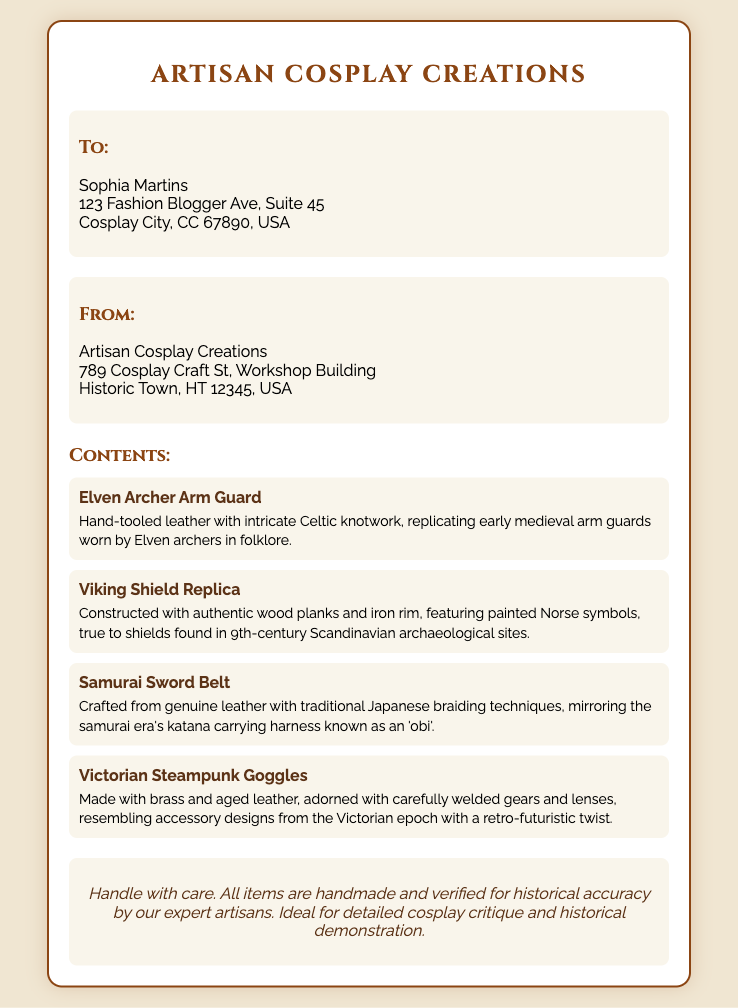What is the name of the recipient? The recipient's name is listed in the 'To' section of the label.
Answer: Sophia Martins What is the shipping origin city? The origin city is provided in the 'From' section of the label.
Answer: Historic Town What item features Celtic knotwork? The item description mentions Celtic knotwork specifically for the arm guard.
Answer: Elven Archer Arm Guard How many items are listed in the contents? The total items can be counted from the list under 'Contents'.
Answer: Four What material is the Viking Shield Replica made from? The item description states the materials used for the Viking Shield Replica.
Answer: Authentic wood planks and iron rim What are the special instructions for handling the items? The instructions highlight how the items should be treated during shipping.
Answer: Handle with care What is the historical period for the samurai sword belt? The belt's description refers to a specific historical context.
Answer: Samurai era What type of craftsmanship is emphasized for the items? The description includes the quality and attention to detail in creating the items.
Answer: Handmade and verified for historical accuracy 